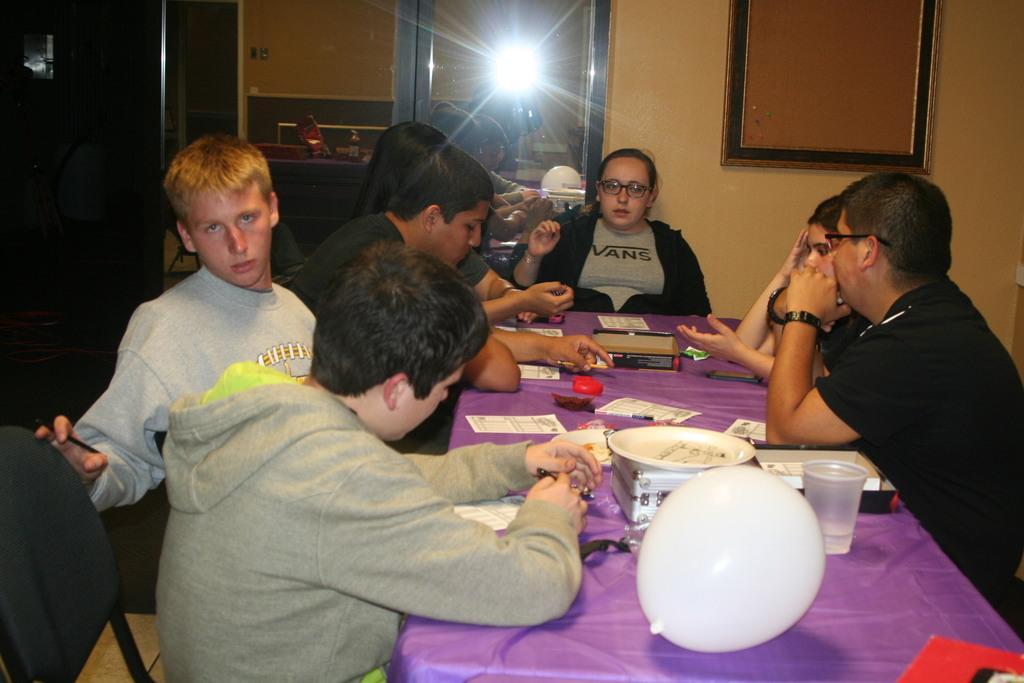Describe this image in one or two sentences. In the image we can see there are people who are sitting on chair and on the table we can see there is a balloon, glass and in a plate there are snacks. 